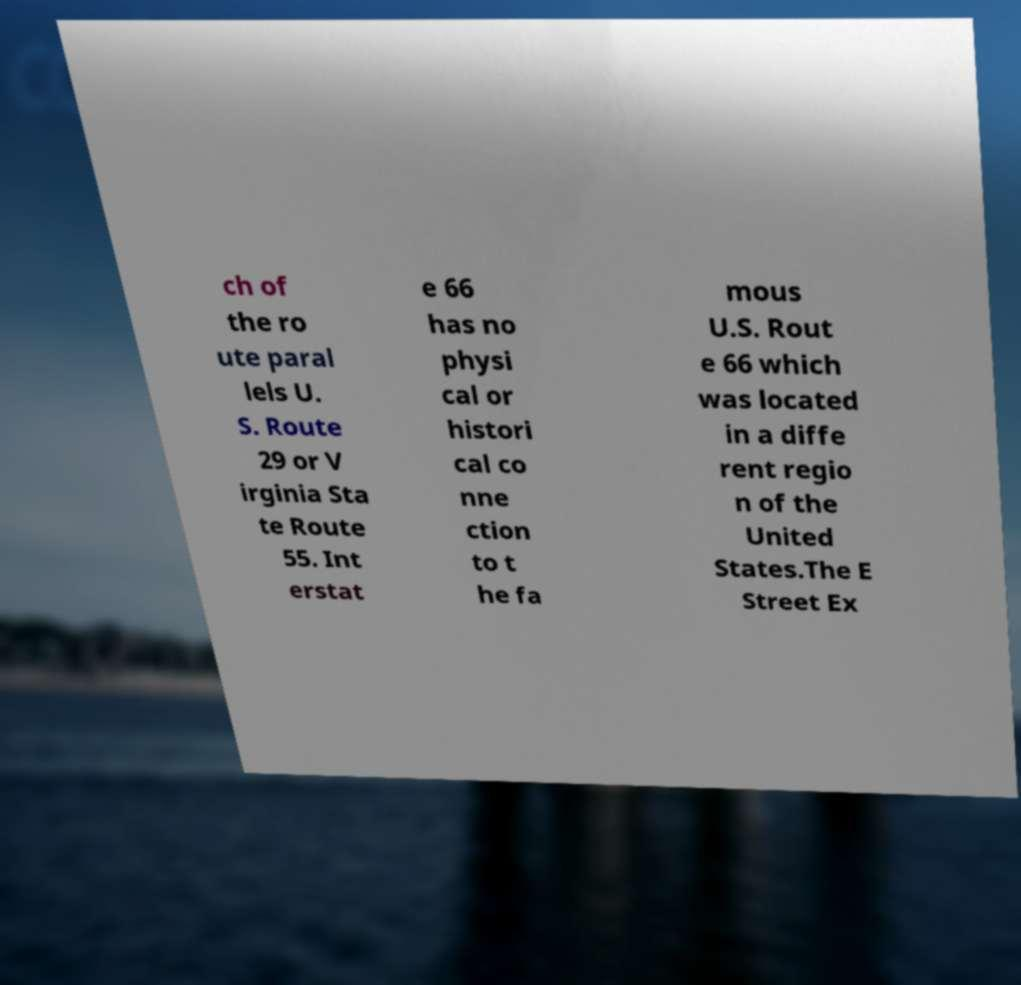I need the written content from this picture converted into text. Can you do that? ch of the ro ute paral lels U. S. Route 29 or V irginia Sta te Route 55. Int erstat e 66 has no physi cal or histori cal co nne ction to t he fa mous U.S. Rout e 66 which was located in a diffe rent regio n of the United States.The E Street Ex 